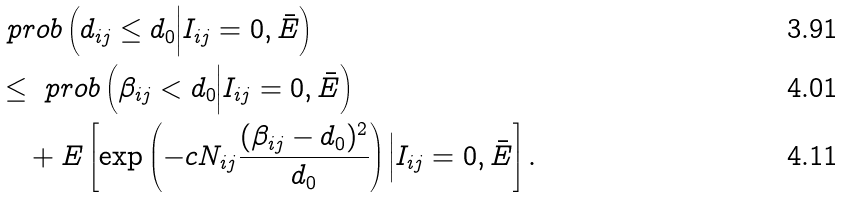Convert formula to latex. <formula><loc_0><loc_0><loc_500><loc_500>& \ p r o b \left ( d _ { i j } \leq d _ { 0 } \Big | I _ { i j } = 0 , \bar { E } \right ) \\ & \leq \ p r o b \left ( \beta _ { i j } < d _ { 0 } \Big | I _ { i j } = 0 , \bar { E } \right ) \\ & \quad + E \left [ \exp \left ( - c N _ { i j } \frac { ( \beta _ { i j } - d _ { 0 } ) ^ { 2 } } { d _ { 0 } } \right ) \Big | I _ { i j } = 0 , \bar { E } \right ] .</formula> 